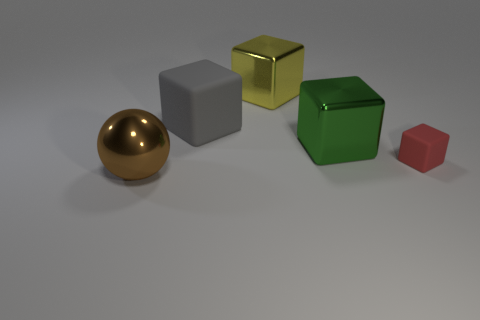Subtract all red cubes. How many cubes are left? 3 Add 2 big balls. How many objects exist? 7 Subtract all yellow blocks. How many blocks are left? 3 Subtract all balls. How many objects are left? 4 Subtract all brown cubes. Subtract all brown cylinders. How many cubes are left? 4 Add 1 red cubes. How many red cubes exist? 2 Subtract 0 red balls. How many objects are left? 5 Subtract all red things. Subtract all tiny red rubber things. How many objects are left? 3 Add 4 large metallic blocks. How many large metallic blocks are left? 6 